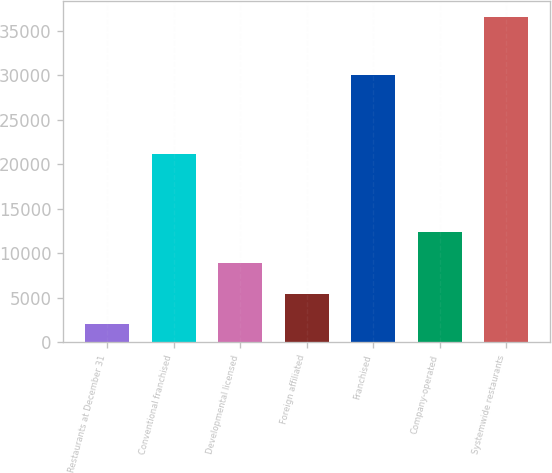Convert chart to OTSL. <chart><loc_0><loc_0><loc_500><loc_500><bar_chart><fcel>Restaurants at December 31<fcel>Conventional franchised<fcel>Developmental licensed<fcel>Foreign affiliated<fcel>Franchised<fcel>Company-operated<fcel>Systemwide restaurants<nl><fcel>2015<fcel>21147<fcel>8917<fcel>5466<fcel>30081<fcel>12368<fcel>36525<nl></chart> 